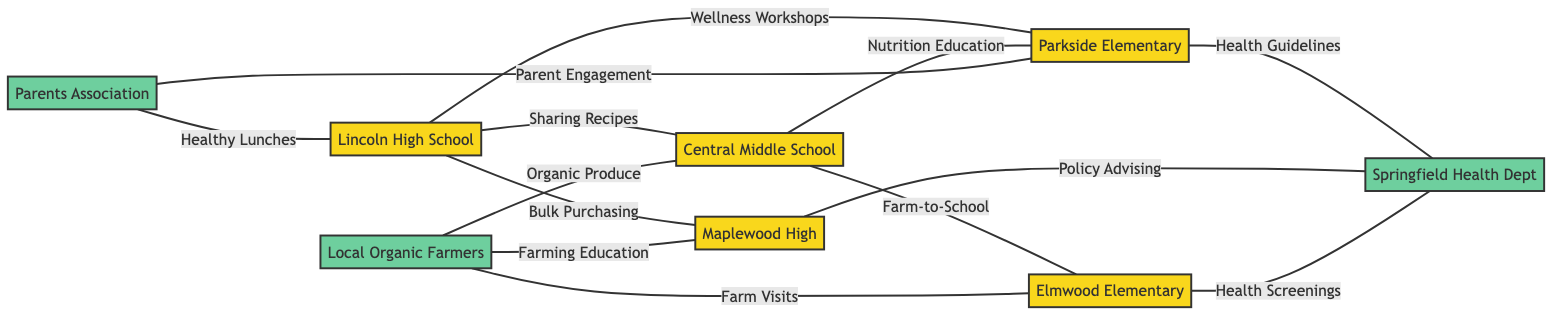What is the total number of nodes in the diagram? The diagram contains a total of eight distinct nodes representing various schools and organizations involved in healthy lunch initiatives.
Answer: 8 Which school collaborates with Central Middle School for the Farm-to-School Program? Looking at the edges connecting Central Middle School, we see that it collaborates with Elmwood Elementary School specifically for the Farm-to-School Program.
Answer: Elmwood Elementary School How many connections does Lincoln High School have? Upon examining Lincoln High School, it is connected to four other nodes in the graph: Central Middle School, Parkside Elementary School, Maplewood High School, and the Parents Association.
Answer: 4 What is the relationship between Parkside Elementary School and Springfield Health Department? Checking the edges linked to Parkside Elementary School reveals that it has a connection labeled "Health Guidelines Consultation" with the Springfield Health Department.
Answer: Health Guidelines Consultation Which organization supports Local Organic Farmers Cooperative? By analyzing the edges, Local Organic Farmers Cooperative connects with three schools: Central Middle School, Maplewood High School, and Elmwood Elementary School, but the specific supports mentioned are Organic Produce Supply for Central Middle School, Sustainable Farming Education for Maplewood High School, and Farm Visits and Workshops for Elmwood Elementary School.
Answer: Central Middle School, Maplewood High School, Elmwood Elementary School How many total edges are present in the diagram? Counting the edges listed reveals there are twelve distinct edges representing collaborations or relationships among the nodes in the graph.
Answer: 12 Which school has the most connections? By analyzing all nodes, Lincoln High School has the highest number of connections, with four edges tied to it in the diagram.
Answer: Lincoln High School What type of initiative connects Parkside Elementary School and Central Middle School? The edge between Parkside Elementary School and Central Middle School is labeled "Coordinated Nutrition Education," indicating the nature of their collaboration.
Answer: Coordinated Nutrition Education Which organization is involved in health screenings for Elmwood Elementary School? The edge connecting Elmwood Elementary School to the Springfield Health Department indicates that this organization is involved in conducting health screenings for Elmwood Elementary School.
Answer: Springfield Health Department 